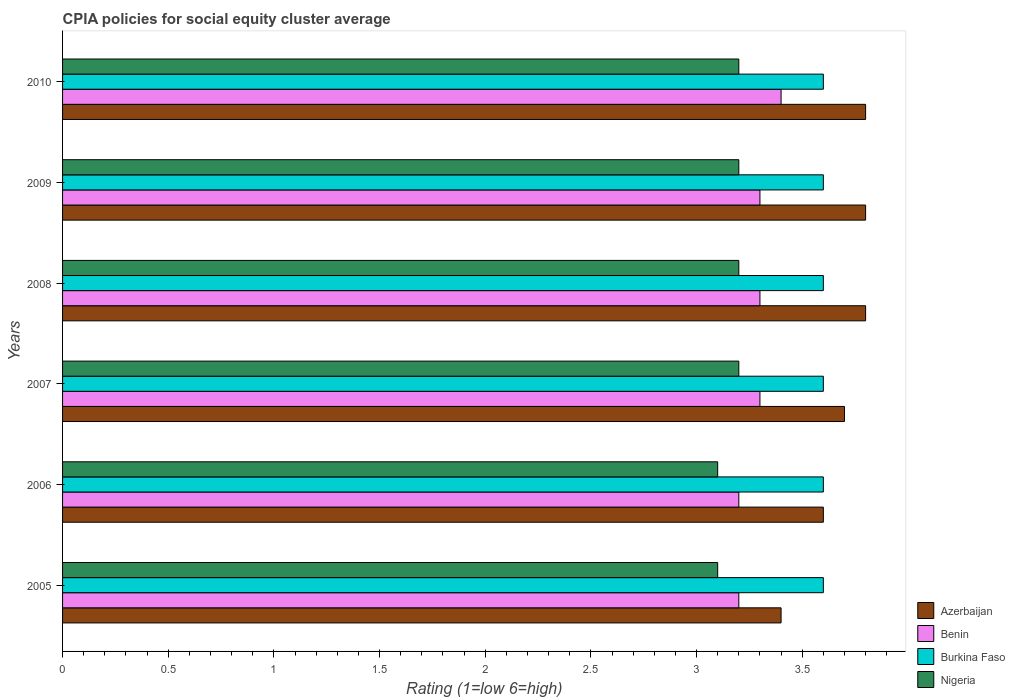How many groups of bars are there?
Ensure brevity in your answer.  6. Are the number of bars on each tick of the Y-axis equal?
Your answer should be very brief. Yes. What is the CPIA rating in Burkina Faso in 2006?
Offer a terse response. 3.6. What is the difference between the CPIA rating in Benin in 2005 and that in 2010?
Give a very brief answer. -0.2. What is the difference between the CPIA rating in Burkina Faso in 2006 and the CPIA rating in Benin in 2007?
Keep it short and to the point. 0.3. What is the average CPIA rating in Burkina Faso per year?
Provide a short and direct response. 3.6. In the year 2010, what is the difference between the CPIA rating in Burkina Faso and CPIA rating in Azerbaijan?
Provide a succinct answer. -0.2. What is the ratio of the CPIA rating in Burkina Faso in 2006 to that in 2010?
Make the answer very short. 1. Is the CPIA rating in Benin in 2007 less than that in 2010?
Give a very brief answer. Yes. What is the difference between the highest and the lowest CPIA rating in Nigeria?
Keep it short and to the point. 0.1. In how many years, is the CPIA rating in Nigeria greater than the average CPIA rating in Nigeria taken over all years?
Your answer should be compact. 4. What does the 1st bar from the top in 2006 represents?
Provide a succinct answer. Nigeria. What does the 3rd bar from the bottom in 2006 represents?
Keep it short and to the point. Burkina Faso. How many years are there in the graph?
Offer a terse response. 6. What is the difference between two consecutive major ticks on the X-axis?
Give a very brief answer. 0.5. Does the graph contain any zero values?
Keep it short and to the point. No. Where does the legend appear in the graph?
Keep it short and to the point. Bottom right. How are the legend labels stacked?
Provide a succinct answer. Vertical. What is the title of the graph?
Your answer should be very brief. CPIA policies for social equity cluster average. What is the label or title of the X-axis?
Make the answer very short. Rating (1=low 6=high). What is the label or title of the Y-axis?
Make the answer very short. Years. What is the Rating (1=low 6=high) of Azerbaijan in 2005?
Make the answer very short. 3.4. What is the Rating (1=low 6=high) of Benin in 2005?
Your answer should be very brief. 3.2. What is the Rating (1=low 6=high) in Burkina Faso in 2005?
Offer a terse response. 3.6. What is the Rating (1=low 6=high) of Benin in 2006?
Offer a terse response. 3.2. What is the Rating (1=low 6=high) of Burkina Faso in 2006?
Make the answer very short. 3.6. What is the Rating (1=low 6=high) of Burkina Faso in 2007?
Offer a terse response. 3.6. What is the Rating (1=low 6=high) in Azerbaijan in 2009?
Give a very brief answer. 3.8. What is the Rating (1=low 6=high) of Benin in 2009?
Offer a terse response. 3.3. What is the Rating (1=low 6=high) in Azerbaijan in 2010?
Provide a succinct answer. 3.8. What is the Rating (1=low 6=high) of Nigeria in 2010?
Offer a terse response. 3.2. Across all years, what is the maximum Rating (1=low 6=high) in Azerbaijan?
Give a very brief answer. 3.8. Across all years, what is the maximum Rating (1=low 6=high) in Benin?
Keep it short and to the point. 3.4. Across all years, what is the minimum Rating (1=low 6=high) of Nigeria?
Your answer should be compact. 3.1. What is the total Rating (1=low 6=high) in Azerbaijan in the graph?
Offer a terse response. 22.1. What is the total Rating (1=low 6=high) in Burkina Faso in the graph?
Your response must be concise. 21.6. What is the difference between the Rating (1=low 6=high) in Benin in 2005 and that in 2006?
Provide a succinct answer. 0. What is the difference between the Rating (1=low 6=high) of Azerbaijan in 2005 and that in 2007?
Your answer should be very brief. -0.3. What is the difference between the Rating (1=low 6=high) in Benin in 2005 and that in 2007?
Your answer should be compact. -0.1. What is the difference between the Rating (1=low 6=high) of Azerbaijan in 2005 and that in 2008?
Provide a succinct answer. -0.4. What is the difference between the Rating (1=low 6=high) in Benin in 2005 and that in 2008?
Offer a very short reply. -0.1. What is the difference between the Rating (1=low 6=high) of Nigeria in 2005 and that in 2008?
Provide a succinct answer. -0.1. What is the difference between the Rating (1=low 6=high) in Azerbaijan in 2005 and that in 2009?
Your answer should be compact. -0.4. What is the difference between the Rating (1=low 6=high) of Benin in 2005 and that in 2009?
Make the answer very short. -0.1. What is the difference between the Rating (1=low 6=high) in Burkina Faso in 2005 and that in 2010?
Your answer should be compact. 0. What is the difference between the Rating (1=low 6=high) of Benin in 2006 and that in 2007?
Offer a very short reply. -0.1. What is the difference between the Rating (1=low 6=high) of Nigeria in 2006 and that in 2008?
Your answer should be compact. -0.1. What is the difference between the Rating (1=low 6=high) of Benin in 2006 and that in 2009?
Offer a very short reply. -0.1. What is the difference between the Rating (1=low 6=high) in Nigeria in 2006 and that in 2009?
Offer a very short reply. -0.1. What is the difference between the Rating (1=low 6=high) of Azerbaijan in 2006 and that in 2010?
Offer a very short reply. -0.2. What is the difference between the Rating (1=low 6=high) of Burkina Faso in 2006 and that in 2010?
Offer a terse response. 0. What is the difference between the Rating (1=low 6=high) in Benin in 2007 and that in 2008?
Make the answer very short. 0. What is the difference between the Rating (1=low 6=high) in Azerbaijan in 2007 and that in 2010?
Keep it short and to the point. -0.1. What is the difference between the Rating (1=low 6=high) in Benin in 2007 and that in 2010?
Give a very brief answer. -0.1. What is the difference between the Rating (1=low 6=high) of Benin in 2008 and that in 2009?
Ensure brevity in your answer.  0. What is the difference between the Rating (1=low 6=high) of Nigeria in 2008 and that in 2009?
Your answer should be very brief. 0. What is the difference between the Rating (1=low 6=high) in Azerbaijan in 2008 and that in 2010?
Your answer should be very brief. 0. What is the difference between the Rating (1=low 6=high) of Burkina Faso in 2008 and that in 2010?
Provide a succinct answer. 0. What is the difference between the Rating (1=low 6=high) in Azerbaijan in 2009 and that in 2010?
Offer a very short reply. 0. What is the difference between the Rating (1=low 6=high) in Burkina Faso in 2009 and that in 2010?
Provide a short and direct response. 0. What is the difference between the Rating (1=low 6=high) in Benin in 2005 and the Rating (1=low 6=high) in Burkina Faso in 2006?
Your answer should be compact. -0.4. What is the difference between the Rating (1=low 6=high) of Benin in 2005 and the Rating (1=low 6=high) of Nigeria in 2006?
Offer a terse response. 0.1. What is the difference between the Rating (1=low 6=high) of Burkina Faso in 2005 and the Rating (1=low 6=high) of Nigeria in 2006?
Provide a short and direct response. 0.5. What is the difference between the Rating (1=low 6=high) in Benin in 2005 and the Rating (1=low 6=high) in Burkina Faso in 2007?
Offer a very short reply. -0.4. What is the difference between the Rating (1=low 6=high) of Benin in 2005 and the Rating (1=low 6=high) of Nigeria in 2007?
Your answer should be very brief. 0. What is the difference between the Rating (1=low 6=high) in Burkina Faso in 2005 and the Rating (1=low 6=high) in Nigeria in 2007?
Ensure brevity in your answer.  0.4. What is the difference between the Rating (1=low 6=high) in Azerbaijan in 2005 and the Rating (1=low 6=high) in Burkina Faso in 2008?
Make the answer very short. -0.2. What is the difference between the Rating (1=low 6=high) of Azerbaijan in 2005 and the Rating (1=low 6=high) of Nigeria in 2008?
Provide a succinct answer. 0.2. What is the difference between the Rating (1=low 6=high) in Benin in 2005 and the Rating (1=low 6=high) in Burkina Faso in 2008?
Provide a succinct answer. -0.4. What is the difference between the Rating (1=low 6=high) in Benin in 2005 and the Rating (1=low 6=high) in Nigeria in 2008?
Provide a short and direct response. 0. What is the difference between the Rating (1=low 6=high) in Burkina Faso in 2005 and the Rating (1=low 6=high) in Nigeria in 2008?
Give a very brief answer. 0.4. What is the difference between the Rating (1=low 6=high) in Azerbaijan in 2005 and the Rating (1=low 6=high) in Benin in 2009?
Give a very brief answer. 0.1. What is the difference between the Rating (1=low 6=high) of Benin in 2005 and the Rating (1=low 6=high) of Burkina Faso in 2009?
Provide a succinct answer. -0.4. What is the difference between the Rating (1=low 6=high) in Benin in 2005 and the Rating (1=low 6=high) in Nigeria in 2009?
Your answer should be very brief. 0. What is the difference between the Rating (1=low 6=high) in Burkina Faso in 2005 and the Rating (1=low 6=high) in Nigeria in 2009?
Ensure brevity in your answer.  0.4. What is the difference between the Rating (1=low 6=high) in Azerbaijan in 2005 and the Rating (1=low 6=high) in Burkina Faso in 2010?
Make the answer very short. -0.2. What is the difference between the Rating (1=low 6=high) in Benin in 2005 and the Rating (1=low 6=high) in Burkina Faso in 2010?
Offer a very short reply. -0.4. What is the difference between the Rating (1=low 6=high) of Azerbaijan in 2006 and the Rating (1=low 6=high) of Benin in 2007?
Make the answer very short. 0.3. What is the difference between the Rating (1=low 6=high) in Azerbaijan in 2006 and the Rating (1=low 6=high) in Burkina Faso in 2007?
Offer a terse response. 0. What is the difference between the Rating (1=low 6=high) of Azerbaijan in 2006 and the Rating (1=low 6=high) of Nigeria in 2007?
Make the answer very short. 0.4. What is the difference between the Rating (1=low 6=high) in Benin in 2006 and the Rating (1=low 6=high) in Burkina Faso in 2007?
Keep it short and to the point. -0.4. What is the difference between the Rating (1=low 6=high) of Benin in 2006 and the Rating (1=low 6=high) of Nigeria in 2007?
Provide a short and direct response. 0. What is the difference between the Rating (1=low 6=high) of Azerbaijan in 2006 and the Rating (1=low 6=high) of Burkina Faso in 2008?
Provide a succinct answer. 0. What is the difference between the Rating (1=low 6=high) in Azerbaijan in 2006 and the Rating (1=low 6=high) in Nigeria in 2008?
Your answer should be very brief. 0.4. What is the difference between the Rating (1=low 6=high) of Azerbaijan in 2006 and the Rating (1=low 6=high) of Burkina Faso in 2009?
Make the answer very short. 0. What is the difference between the Rating (1=low 6=high) in Burkina Faso in 2006 and the Rating (1=low 6=high) in Nigeria in 2009?
Keep it short and to the point. 0.4. What is the difference between the Rating (1=low 6=high) in Azerbaijan in 2006 and the Rating (1=low 6=high) in Burkina Faso in 2010?
Offer a terse response. 0. What is the difference between the Rating (1=low 6=high) in Burkina Faso in 2006 and the Rating (1=low 6=high) in Nigeria in 2010?
Ensure brevity in your answer.  0.4. What is the difference between the Rating (1=low 6=high) in Azerbaijan in 2007 and the Rating (1=low 6=high) in Benin in 2008?
Your response must be concise. 0.4. What is the difference between the Rating (1=low 6=high) in Azerbaijan in 2007 and the Rating (1=low 6=high) in Nigeria in 2008?
Ensure brevity in your answer.  0.5. What is the difference between the Rating (1=low 6=high) of Benin in 2007 and the Rating (1=low 6=high) of Nigeria in 2008?
Your answer should be compact. 0.1. What is the difference between the Rating (1=low 6=high) in Benin in 2007 and the Rating (1=low 6=high) in Burkina Faso in 2009?
Ensure brevity in your answer.  -0.3. What is the difference between the Rating (1=low 6=high) in Benin in 2007 and the Rating (1=low 6=high) in Nigeria in 2009?
Keep it short and to the point. 0.1. What is the difference between the Rating (1=low 6=high) of Burkina Faso in 2007 and the Rating (1=low 6=high) of Nigeria in 2009?
Provide a succinct answer. 0.4. What is the difference between the Rating (1=low 6=high) of Benin in 2007 and the Rating (1=low 6=high) of Burkina Faso in 2010?
Provide a succinct answer. -0.3. What is the difference between the Rating (1=low 6=high) of Burkina Faso in 2007 and the Rating (1=low 6=high) of Nigeria in 2010?
Give a very brief answer. 0.4. What is the difference between the Rating (1=low 6=high) of Azerbaijan in 2008 and the Rating (1=low 6=high) of Nigeria in 2009?
Your answer should be very brief. 0.6. What is the difference between the Rating (1=low 6=high) of Benin in 2008 and the Rating (1=low 6=high) of Nigeria in 2009?
Provide a short and direct response. 0.1. What is the difference between the Rating (1=low 6=high) of Burkina Faso in 2008 and the Rating (1=low 6=high) of Nigeria in 2009?
Provide a short and direct response. 0.4. What is the difference between the Rating (1=low 6=high) in Azerbaijan in 2008 and the Rating (1=low 6=high) in Benin in 2010?
Ensure brevity in your answer.  0.4. What is the difference between the Rating (1=low 6=high) of Azerbaijan in 2008 and the Rating (1=low 6=high) of Nigeria in 2010?
Ensure brevity in your answer.  0.6. What is the difference between the Rating (1=low 6=high) in Benin in 2008 and the Rating (1=low 6=high) in Burkina Faso in 2010?
Make the answer very short. -0.3. What is the difference between the Rating (1=low 6=high) in Burkina Faso in 2008 and the Rating (1=low 6=high) in Nigeria in 2010?
Offer a very short reply. 0.4. What is the difference between the Rating (1=low 6=high) of Azerbaijan in 2009 and the Rating (1=low 6=high) of Benin in 2010?
Your answer should be very brief. 0.4. What is the difference between the Rating (1=low 6=high) of Azerbaijan in 2009 and the Rating (1=low 6=high) of Burkina Faso in 2010?
Your answer should be compact. 0.2. What is the difference between the Rating (1=low 6=high) in Burkina Faso in 2009 and the Rating (1=low 6=high) in Nigeria in 2010?
Ensure brevity in your answer.  0.4. What is the average Rating (1=low 6=high) of Azerbaijan per year?
Give a very brief answer. 3.68. What is the average Rating (1=low 6=high) of Benin per year?
Provide a succinct answer. 3.28. What is the average Rating (1=low 6=high) of Nigeria per year?
Make the answer very short. 3.17. In the year 2005, what is the difference between the Rating (1=low 6=high) in Azerbaijan and Rating (1=low 6=high) in Benin?
Offer a very short reply. 0.2. In the year 2005, what is the difference between the Rating (1=low 6=high) in Benin and Rating (1=low 6=high) in Burkina Faso?
Your response must be concise. -0.4. In the year 2005, what is the difference between the Rating (1=low 6=high) in Benin and Rating (1=low 6=high) in Nigeria?
Provide a short and direct response. 0.1. In the year 2005, what is the difference between the Rating (1=low 6=high) in Burkina Faso and Rating (1=low 6=high) in Nigeria?
Provide a succinct answer. 0.5. In the year 2006, what is the difference between the Rating (1=low 6=high) in Azerbaijan and Rating (1=low 6=high) in Benin?
Your response must be concise. 0.4. In the year 2006, what is the difference between the Rating (1=low 6=high) of Azerbaijan and Rating (1=low 6=high) of Burkina Faso?
Offer a very short reply. 0. In the year 2006, what is the difference between the Rating (1=low 6=high) in Azerbaijan and Rating (1=low 6=high) in Nigeria?
Make the answer very short. 0.5. In the year 2006, what is the difference between the Rating (1=low 6=high) in Benin and Rating (1=low 6=high) in Nigeria?
Your answer should be very brief. 0.1. In the year 2007, what is the difference between the Rating (1=low 6=high) in Azerbaijan and Rating (1=low 6=high) in Benin?
Provide a succinct answer. 0.4. In the year 2007, what is the difference between the Rating (1=low 6=high) of Azerbaijan and Rating (1=low 6=high) of Burkina Faso?
Provide a succinct answer. 0.1. In the year 2007, what is the difference between the Rating (1=low 6=high) in Benin and Rating (1=low 6=high) in Nigeria?
Provide a short and direct response. 0.1. In the year 2007, what is the difference between the Rating (1=low 6=high) of Burkina Faso and Rating (1=low 6=high) of Nigeria?
Provide a short and direct response. 0.4. In the year 2008, what is the difference between the Rating (1=low 6=high) of Burkina Faso and Rating (1=low 6=high) of Nigeria?
Make the answer very short. 0.4. In the year 2009, what is the difference between the Rating (1=low 6=high) in Azerbaijan and Rating (1=low 6=high) in Benin?
Give a very brief answer. 0.5. In the year 2009, what is the difference between the Rating (1=low 6=high) of Azerbaijan and Rating (1=low 6=high) of Burkina Faso?
Offer a terse response. 0.2. In the year 2009, what is the difference between the Rating (1=low 6=high) in Azerbaijan and Rating (1=low 6=high) in Nigeria?
Your answer should be very brief. 0.6. In the year 2010, what is the difference between the Rating (1=low 6=high) of Azerbaijan and Rating (1=low 6=high) of Benin?
Give a very brief answer. 0.4. In the year 2010, what is the difference between the Rating (1=low 6=high) of Azerbaijan and Rating (1=low 6=high) of Nigeria?
Provide a short and direct response. 0.6. In the year 2010, what is the difference between the Rating (1=low 6=high) of Benin and Rating (1=low 6=high) of Burkina Faso?
Provide a short and direct response. -0.2. What is the ratio of the Rating (1=low 6=high) of Benin in 2005 to that in 2006?
Provide a short and direct response. 1. What is the ratio of the Rating (1=low 6=high) of Azerbaijan in 2005 to that in 2007?
Provide a short and direct response. 0.92. What is the ratio of the Rating (1=low 6=high) of Benin in 2005 to that in 2007?
Keep it short and to the point. 0.97. What is the ratio of the Rating (1=low 6=high) in Nigeria in 2005 to that in 2007?
Ensure brevity in your answer.  0.97. What is the ratio of the Rating (1=low 6=high) in Azerbaijan in 2005 to that in 2008?
Offer a very short reply. 0.89. What is the ratio of the Rating (1=low 6=high) in Benin in 2005 to that in 2008?
Your answer should be very brief. 0.97. What is the ratio of the Rating (1=low 6=high) in Nigeria in 2005 to that in 2008?
Give a very brief answer. 0.97. What is the ratio of the Rating (1=low 6=high) of Azerbaijan in 2005 to that in 2009?
Give a very brief answer. 0.89. What is the ratio of the Rating (1=low 6=high) in Benin in 2005 to that in 2009?
Your response must be concise. 0.97. What is the ratio of the Rating (1=low 6=high) in Nigeria in 2005 to that in 2009?
Offer a terse response. 0.97. What is the ratio of the Rating (1=low 6=high) of Azerbaijan in 2005 to that in 2010?
Ensure brevity in your answer.  0.89. What is the ratio of the Rating (1=low 6=high) of Benin in 2005 to that in 2010?
Your answer should be compact. 0.94. What is the ratio of the Rating (1=low 6=high) in Nigeria in 2005 to that in 2010?
Your answer should be compact. 0.97. What is the ratio of the Rating (1=low 6=high) in Benin in 2006 to that in 2007?
Your response must be concise. 0.97. What is the ratio of the Rating (1=low 6=high) of Burkina Faso in 2006 to that in 2007?
Offer a terse response. 1. What is the ratio of the Rating (1=low 6=high) in Nigeria in 2006 to that in 2007?
Provide a succinct answer. 0.97. What is the ratio of the Rating (1=low 6=high) in Benin in 2006 to that in 2008?
Ensure brevity in your answer.  0.97. What is the ratio of the Rating (1=low 6=high) in Nigeria in 2006 to that in 2008?
Offer a very short reply. 0.97. What is the ratio of the Rating (1=low 6=high) in Azerbaijan in 2006 to that in 2009?
Offer a very short reply. 0.95. What is the ratio of the Rating (1=low 6=high) in Benin in 2006 to that in 2009?
Offer a very short reply. 0.97. What is the ratio of the Rating (1=low 6=high) in Burkina Faso in 2006 to that in 2009?
Make the answer very short. 1. What is the ratio of the Rating (1=low 6=high) in Nigeria in 2006 to that in 2009?
Your response must be concise. 0.97. What is the ratio of the Rating (1=low 6=high) of Azerbaijan in 2006 to that in 2010?
Your response must be concise. 0.95. What is the ratio of the Rating (1=low 6=high) in Nigeria in 2006 to that in 2010?
Your response must be concise. 0.97. What is the ratio of the Rating (1=low 6=high) of Azerbaijan in 2007 to that in 2008?
Your answer should be very brief. 0.97. What is the ratio of the Rating (1=low 6=high) of Burkina Faso in 2007 to that in 2008?
Provide a succinct answer. 1. What is the ratio of the Rating (1=low 6=high) of Azerbaijan in 2007 to that in 2009?
Your answer should be compact. 0.97. What is the ratio of the Rating (1=low 6=high) in Burkina Faso in 2007 to that in 2009?
Offer a very short reply. 1. What is the ratio of the Rating (1=low 6=high) in Azerbaijan in 2007 to that in 2010?
Make the answer very short. 0.97. What is the ratio of the Rating (1=low 6=high) of Benin in 2007 to that in 2010?
Your answer should be compact. 0.97. What is the ratio of the Rating (1=low 6=high) of Burkina Faso in 2007 to that in 2010?
Your response must be concise. 1. What is the ratio of the Rating (1=low 6=high) of Azerbaijan in 2008 to that in 2009?
Your response must be concise. 1. What is the ratio of the Rating (1=low 6=high) of Benin in 2008 to that in 2010?
Offer a terse response. 0.97. What is the ratio of the Rating (1=low 6=high) of Azerbaijan in 2009 to that in 2010?
Your answer should be very brief. 1. What is the ratio of the Rating (1=low 6=high) in Benin in 2009 to that in 2010?
Your response must be concise. 0.97. What is the ratio of the Rating (1=low 6=high) in Nigeria in 2009 to that in 2010?
Provide a short and direct response. 1. What is the difference between the highest and the second highest Rating (1=low 6=high) in Azerbaijan?
Your answer should be very brief. 0. What is the difference between the highest and the second highest Rating (1=low 6=high) of Nigeria?
Offer a terse response. 0. What is the difference between the highest and the lowest Rating (1=low 6=high) of Benin?
Provide a short and direct response. 0.2. What is the difference between the highest and the lowest Rating (1=low 6=high) in Nigeria?
Give a very brief answer. 0.1. 